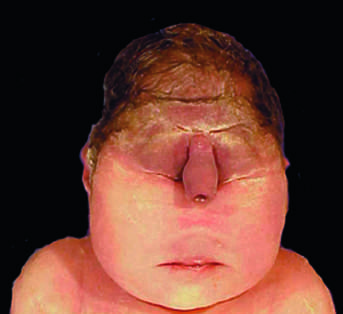s this degree of external dysmorphogenesis associated with severe internal anomalies such as maldevelopment of the brain and cardiac defects in almost all cases?
Answer the question using a single word or phrase. Yes 